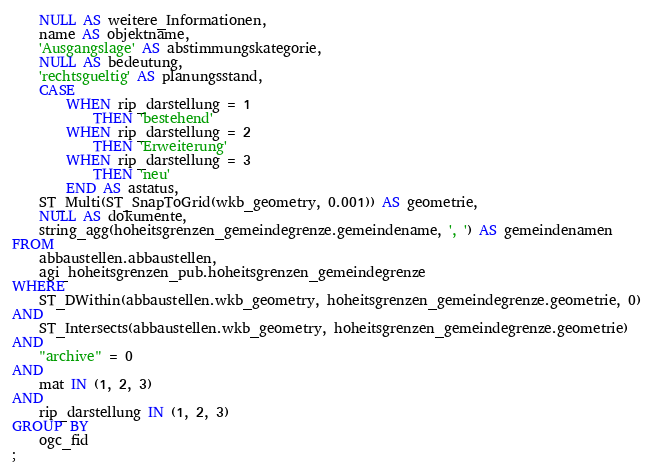<code> <loc_0><loc_0><loc_500><loc_500><_SQL_>    NULL AS weitere_Informationen,
    name AS objektname,
    'Ausgangslage' AS abstimmungskategorie,
    NULL AS bedeutung,
    'rechtsgueltig' AS planungsstand,
    CASE 
        WHEN rip_darstellung = 1
            THEN 'bestehend'
        WHEN rip_darstellung = 2
            THEN 'Erweiterung'
        WHEN rip_darstellung = 3
            THEN 'neu'
        END AS astatus,
    ST_Multi(ST_SnapToGrid(wkb_geometry, 0.001)) AS geometrie,
    NULL AS dokumente,
    string_agg(hoheitsgrenzen_gemeindegrenze.gemeindename, ', ') AS gemeindenamen
FROM
    abbaustellen.abbaustellen,
    agi_hoheitsgrenzen_pub.hoheitsgrenzen_gemeindegrenze
WHERE
    ST_DWithin(abbaustellen.wkb_geometry, hoheitsgrenzen_gemeindegrenze.geometrie, 0)
AND
    ST_Intersects(abbaustellen.wkb_geometry, hoheitsgrenzen_gemeindegrenze.geometrie)
AND
    "archive" = 0
AND
    mat IN (1, 2, 3)
AND
    rip_darstellung IN (1, 2, 3)
GROUP BY
    ogc_fid
;
</code> 